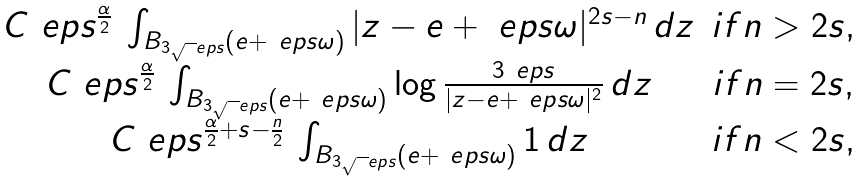<formula> <loc_0><loc_0><loc_500><loc_500>\begin{matrix} C \ e p s ^ { \frac { \alpha } { 2 } } \, \int _ { B _ { 3 \sqrt { \ } e p s } ( e + \ e p s \omega ) } | z - e + \ e p s \omega | ^ { 2 s - n } \, d z & { i f } n > 2 s , \\ C \ e p s ^ { \frac { \alpha } { 2 } } \, \int _ { B _ { 3 \sqrt { \ } e p s } ( e + \ e p s \omega ) } \log \frac { 3 \ e p s } { | z - e + \ e p s \omega | ^ { 2 } } \, d z & { i f } n = 2 s , \\ C \ e p s ^ { \frac { \alpha } { 2 } + s - \frac { n } 2 } \, \int _ { B _ { 3 \sqrt { \ } e p s } ( e + \ e p s \omega ) } 1 \, d z & { i f } n < 2 s , \end{matrix}</formula> 